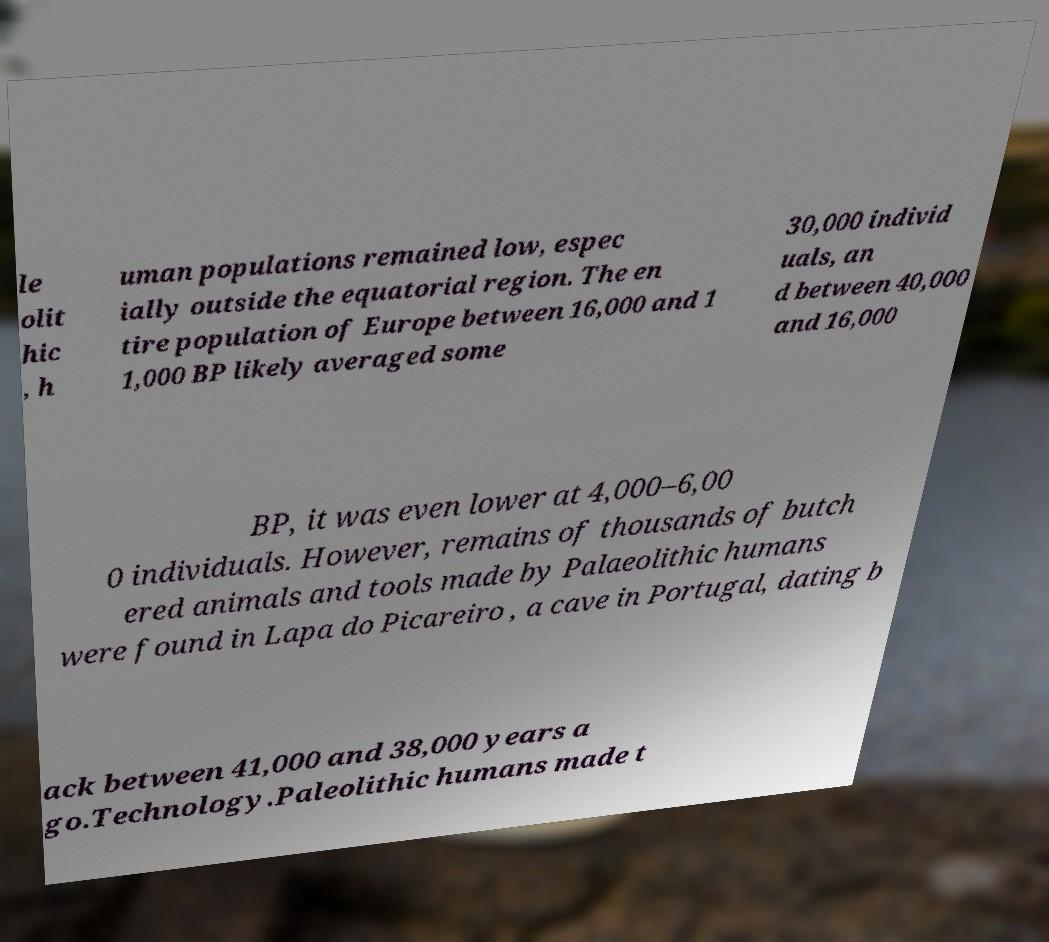Please identify and transcribe the text found in this image. le olit hic , h uman populations remained low, espec ially outside the equatorial region. The en tire population of Europe between 16,000 and 1 1,000 BP likely averaged some 30,000 individ uals, an d between 40,000 and 16,000 BP, it was even lower at 4,000–6,00 0 individuals. However, remains of thousands of butch ered animals and tools made by Palaeolithic humans were found in Lapa do Picareiro , a cave in Portugal, dating b ack between 41,000 and 38,000 years a go.Technology.Paleolithic humans made t 